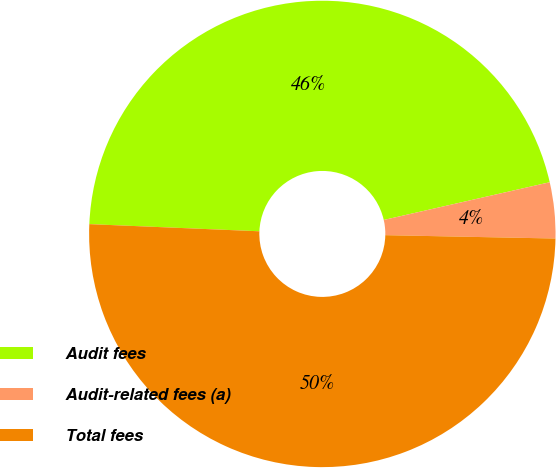Convert chart. <chart><loc_0><loc_0><loc_500><loc_500><pie_chart><fcel>Audit fees<fcel>Audit-related fees (a)<fcel>Total fees<nl><fcel>45.77%<fcel>3.87%<fcel>50.35%<nl></chart> 